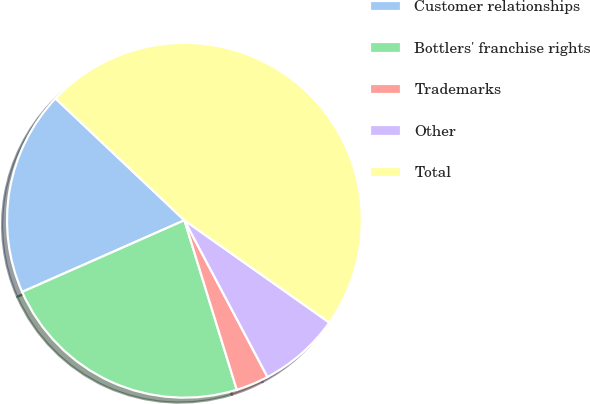Convert chart to OTSL. <chart><loc_0><loc_0><loc_500><loc_500><pie_chart><fcel>Customer relationships<fcel>Bottlers' franchise rights<fcel>Trademarks<fcel>Other<fcel>Total<nl><fcel>18.67%<fcel>23.15%<fcel>2.99%<fcel>7.46%<fcel>47.73%<nl></chart> 